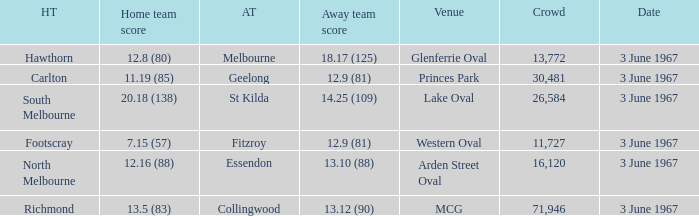Where did Geelong play as the away team? Princes Park. 